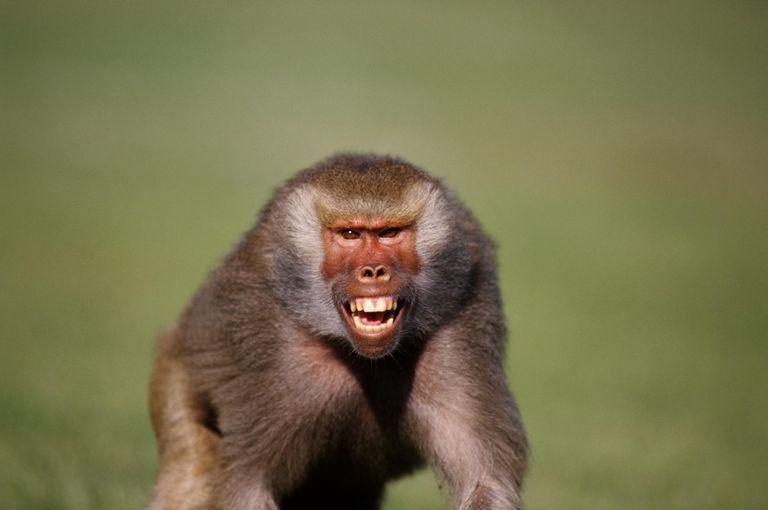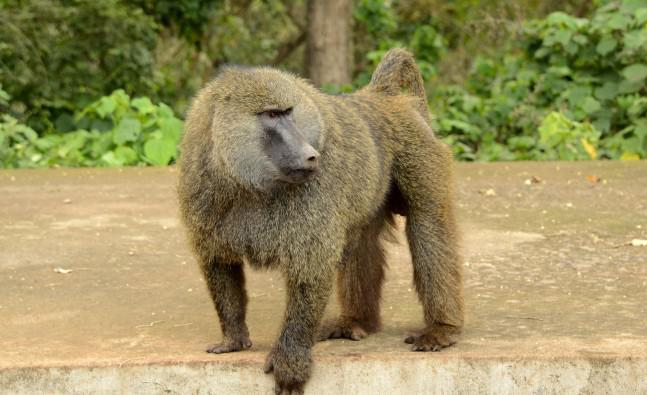The first image is the image on the left, the second image is the image on the right. Assess this claim about the two images: "There is a single animal in the image on the right baring its teeth.". Correct or not? Answer yes or no. No. 